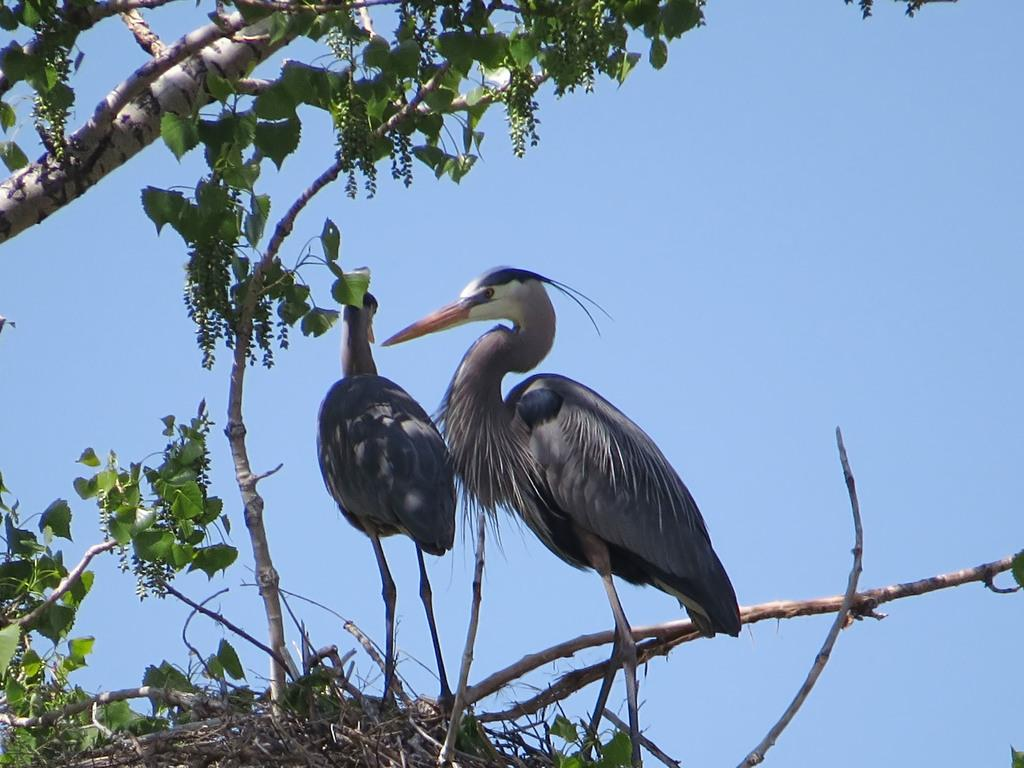What animals can be seen in the image? There are two birds visible on a tree. What is visible in the background of the image? The sky is visible in the background of the image. What type of coal is being used by the men in the image? There are no men or coal present in the image; it features two birds on a tree and the sky in the background. 